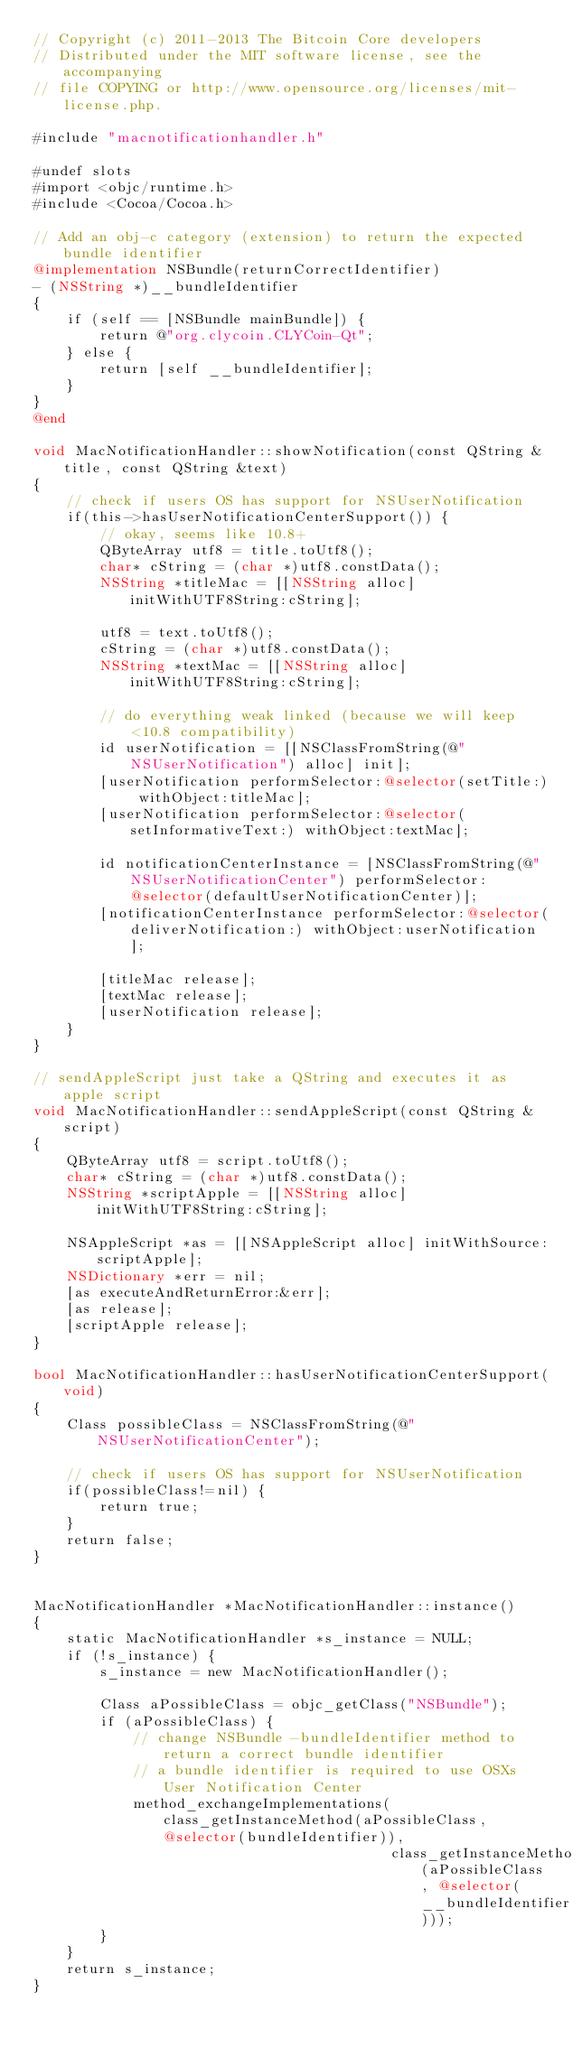Convert code to text. <code><loc_0><loc_0><loc_500><loc_500><_ObjectiveC_>// Copyright (c) 2011-2013 The Bitcoin Core developers
// Distributed under the MIT software license, see the accompanying
// file COPYING or http://www.opensource.org/licenses/mit-license.php.

#include "macnotificationhandler.h"

#undef slots
#import <objc/runtime.h>
#include <Cocoa/Cocoa.h>

// Add an obj-c category (extension) to return the expected bundle identifier
@implementation NSBundle(returnCorrectIdentifier)
- (NSString *)__bundleIdentifier
{
    if (self == [NSBundle mainBundle]) {
        return @"org.clycoin.CLYCoin-Qt";
    } else {
        return [self __bundleIdentifier];
    }
}
@end

void MacNotificationHandler::showNotification(const QString &title, const QString &text)
{
    // check if users OS has support for NSUserNotification
    if(this->hasUserNotificationCenterSupport()) {
        // okay, seems like 10.8+
        QByteArray utf8 = title.toUtf8();
        char* cString = (char *)utf8.constData();
        NSString *titleMac = [[NSString alloc] initWithUTF8String:cString];

        utf8 = text.toUtf8();
        cString = (char *)utf8.constData();
        NSString *textMac = [[NSString alloc] initWithUTF8String:cString];

        // do everything weak linked (because we will keep <10.8 compatibility)
        id userNotification = [[NSClassFromString(@"NSUserNotification") alloc] init];
        [userNotification performSelector:@selector(setTitle:) withObject:titleMac];
        [userNotification performSelector:@selector(setInformativeText:) withObject:textMac];

        id notificationCenterInstance = [NSClassFromString(@"NSUserNotificationCenter") performSelector:@selector(defaultUserNotificationCenter)];
        [notificationCenterInstance performSelector:@selector(deliverNotification:) withObject:userNotification];

        [titleMac release];
        [textMac release];
        [userNotification release];
    }
}

// sendAppleScript just take a QString and executes it as apple script
void MacNotificationHandler::sendAppleScript(const QString &script)
{
    QByteArray utf8 = script.toUtf8();
    char* cString = (char *)utf8.constData();
    NSString *scriptApple = [[NSString alloc] initWithUTF8String:cString];

    NSAppleScript *as = [[NSAppleScript alloc] initWithSource:scriptApple];
    NSDictionary *err = nil;
    [as executeAndReturnError:&err];
    [as release];
    [scriptApple release];
}

bool MacNotificationHandler::hasUserNotificationCenterSupport(void)
{
    Class possibleClass = NSClassFromString(@"NSUserNotificationCenter");

    // check if users OS has support for NSUserNotification
    if(possibleClass!=nil) {
        return true;
    }
    return false;
}


MacNotificationHandler *MacNotificationHandler::instance()
{
    static MacNotificationHandler *s_instance = NULL;
    if (!s_instance) {
        s_instance = new MacNotificationHandler();
        
        Class aPossibleClass = objc_getClass("NSBundle");
        if (aPossibleClass) {
            // change NSBundle -bundleIdentifier method to return a correct bundle identifier
            // a bundle identifier is required to use OSXs User Notification Center
            method_exchangeImplementations(class_getInstanceMethod(aPossibleClass, @selector(bundleIdentifier)),
                                           class_getInstanceMethod(aPossibleClass, @selector(__bundleIdentifier)));
        }
    }
    return s_instance;
}
</code> 